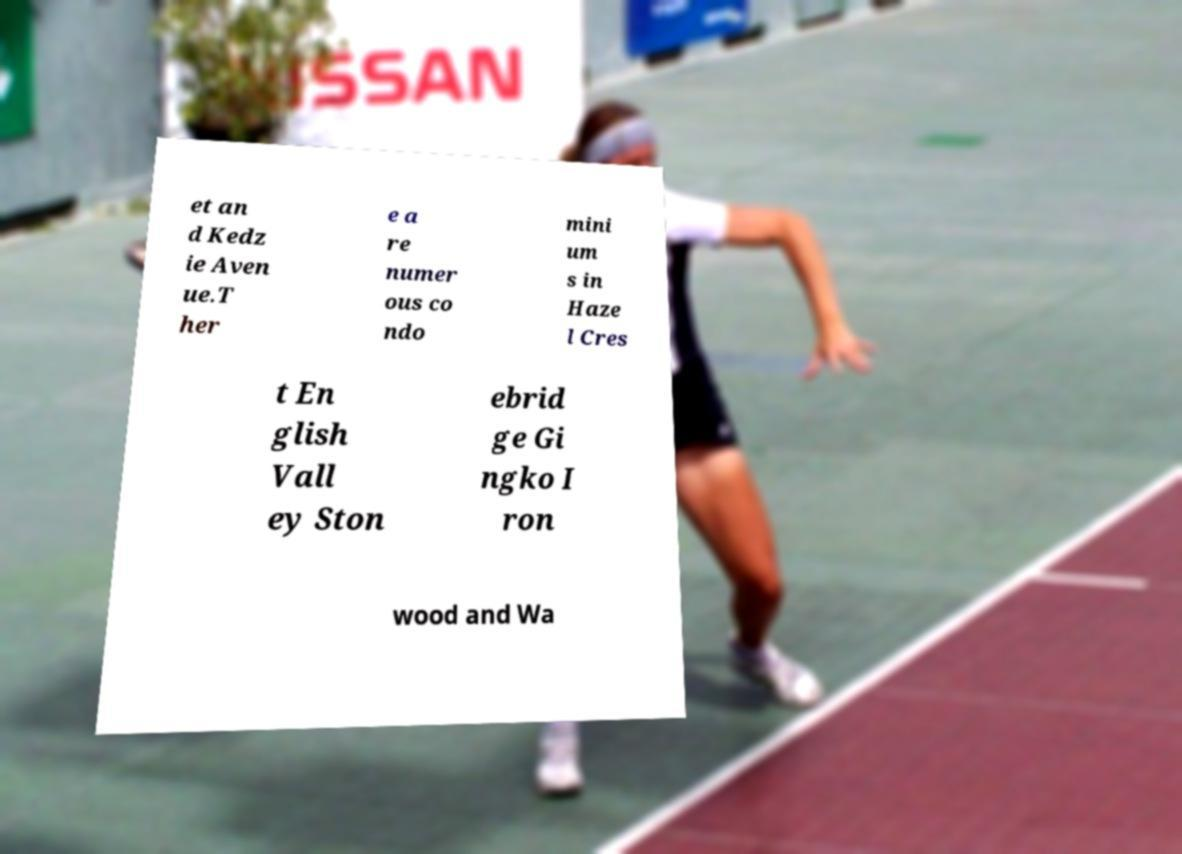For documentation purposes, I need the text within this image transcribed. Could you provide that? et an d Kedz ie Aven ue.T her e a re numer ous co ndo mini um s in Haze l Cres t En glish Vall ey Ston ebrid ge Gi ngko I ron wood and Wa 